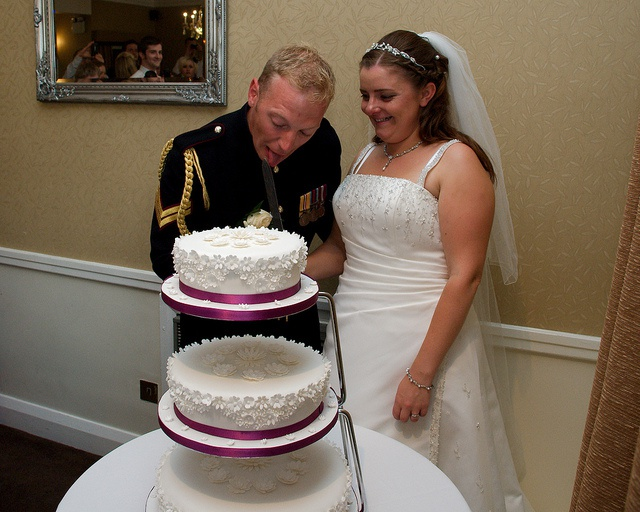Describe the objects in this image and their specific colors. I can see people in olive, darkgray, and gray tones, people in olive, black, brown, and maroon tones, cake in olive, darkgray, gray, and lightgray tones, dining table in olive, lightgray, and darkgray tones, and cake in olive, lightgray, and darkgray tones in this image. 